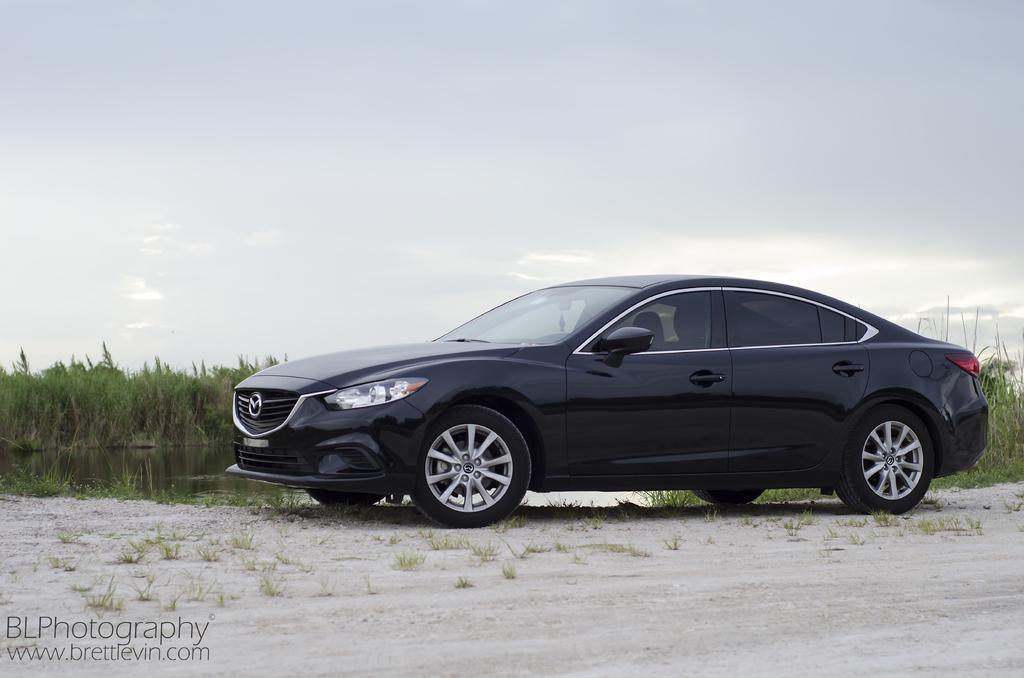Could you give a brief overview of what you see in this image? In this image I can see a car which is black and white in color on the ground. In the background I can see the water, few plants, some grass and the sky. 